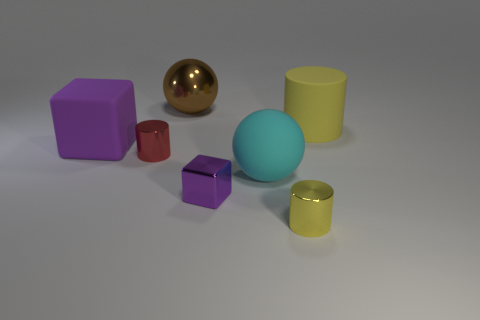What time of day or lighting situation does the image suggest? The image doesn't explicitly suggest a specific time of day, but the lighting appears to be artificial, reminiscent of indoor studio lighting. There's a soft overall illumination with subtle diffuse shadows, indicating a source of diffused light positioned above the objects, creating a calm and controlled ambiance. 